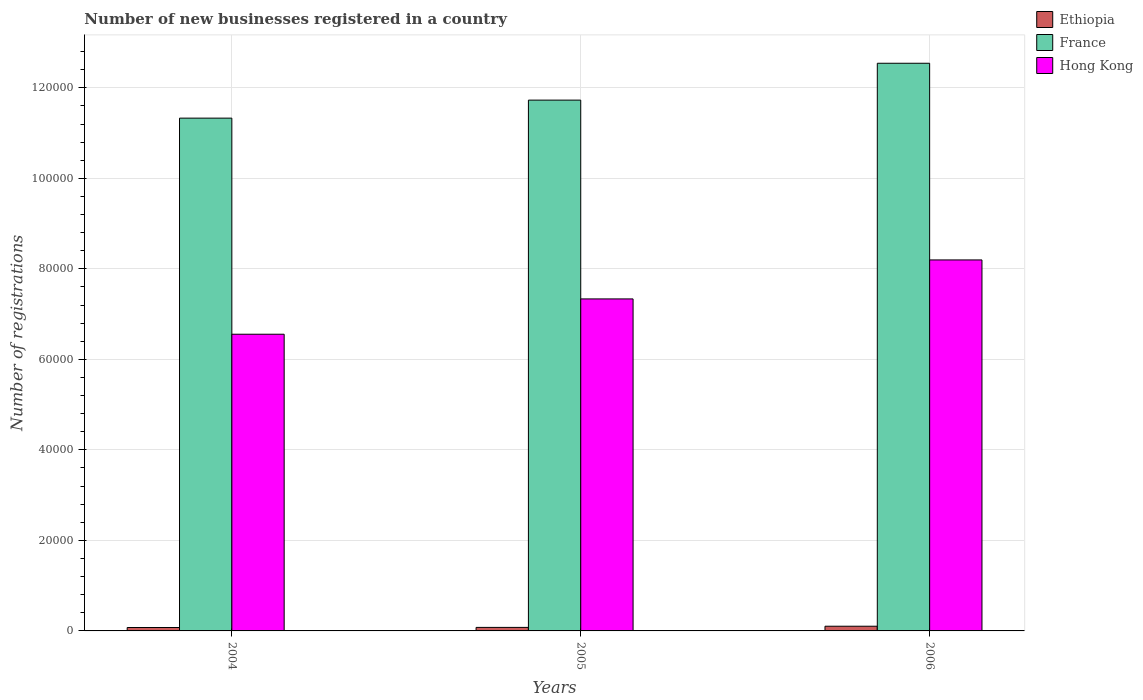How many groups of bars are there?
Offer a very short reply. 3. How many bars are there on the 3rd tick from the right?
Give a very brief answer. 3. What is the number of new businesses registered in France in 2005?
Make the answer very short. 1.17e+05. Across all years, what is the maximum number of new businesses registered in Hong Kong?
Provide a succinct answer. 8.20e+04. Across all years, what is the minimum number of new businesses registered in Hong Kong?
Your answer should be compact. 6.56e+04. In which year was the number of new businesses registered in France maximum?
Provide a succinct answer. 2006. In which year was the number of new businesses registered in Hong Kong minimum?
Offer a very short reply. 2004. What is the total number of new businesses registered in Hong Kong in the graph?
Your answer should be compact. 2.21e+05. What is the difference between the number of new businesses registered in France in 2004 and that in 2006?
Make the answer very short. -1.21e+04. What is the difference between the number of new businesses registered in Hong Kong in 2005 and the number of new businesses registered in Ethiopia in 2004?
Ensure brevity in your answer.  7.26e+04. What is the average number of new businesses registered in Ethiopia per year?
Offer a terse response. 856.33. In the year 2005, what is the difference between the number of new businesses registered in France and number of new businesses registered in Hong Kong?
Your answer should be compact. 4.39e+04. What is the ratio of the number of new businesses registered in Hong Kong in 2005 to that in 2006?
Your answer should be compact. 0.89. Is the number of new businesses registered in Ethiopia in 2004 less than that in 2005?
Your response must be concise. Yes. What is the difference between the highest and the second highest number of new businesses registered in Ethiopia?
Give a very brief answer. 259. What is the difference between the highest and the lowest number of new businesses registered in Ethiopia?
Provide a succinct answer. 283. In how many years, is the number of new businesses registered in Ethiopia greater than the average number of new businesses registered in Ethiopia taken over all years?
Keep it short and to the point. 1. What does the 2nd bar from the left in 2006 represents?
Keep it short and to the point. France. What does the 1st bar from the right in 2004 represents?
Ensure brevity in your answer.  Hong Kong. Is it the case that in every year, the sum of the number of new businesses registered in Ethiopia and number of new businesses registered in France is greater than the number of new businesses registered in Hong Kong?
Offer a very short reply. Yes. How many bars are there?
Your response must be concise. 9. How many years are there in the graph?
Make the answer very short. 3. Are the values on the major ticks of Y-axis written in scientific E-notation?
Your answer should be compact. No. Does the graph contain grids?
Make the answer very short. Yes. Where does the legend appear in the graph?
Make the answer very short. Top right. What is the title of the graph?
Provide a succinct answer. Number of new businesses registered in a country. What is the label or title of the Y-axis?
Offer a very short reply. Number of registrations. What is the Number of registrations of Ethiopia in 2004?
Offer a terse response. 754. What is the Number of registrations in France in 2004?
Your answer should be very brief. 1.13e+05. What is the Number of registrations of Hong Kong in 2004?
Give a very brief answer. 6.56e+04. What is the Number of registrations of Ethiopia in 2005?
Your answer should be very brief. 778. What is the Number of registrations in France in 2005?
Your answer should be very brief. 1.17e+05. What is the Number of registrations in Hong Kong in 2005?
Make the answer very short. 7.34e+04. What is the Number of registrations of Ethiopia in 2006?
Your response must be concise. 1037. What is the Number of registrations in France in 2006?
Keep it short and to the point. 1.25e+05. What is the Number of registrations in Hong Kong in 2006?
Offer a very short reply. 8.20e+04. Across all years, what is the maximum Number of registrations in Ethiopia?
Keep it short and to the point. 1037. Across all years, what is the maximum Number of registrations of France?
Give a very brief answer. 1.25e+05. Across all years, what is the maximum Number of registrations of Hong Kong?
Keep it short and to the point. 8.20e+04. Across all years, what is the minimum Number of registrations in Ethiopia?
Give a very brief answer. 754. Across all years, what is the minimum Number of registrations of France?
Provide a succinct answer. 1.13e+05. Across all years, what is the minimum Number of registrations of Hong Kong?
Ensure brevity in your answer.  6.56e+04. What is the total Number of registrations of Ethiopia in the graph?
Your response must be concise. 2569. What is the total Number of registrations of France in the graph?
Your response must be concise. 3.56e+05. What is the total Number of registrations in Hong Kong in the graph?
Offer a very short reply. 2.21e+05. What is the difference between the Number of registrations of Ethiopia in 2004 and that in 2005?
Ensure brevity in your answer.  -24. What is the difference between the Number of registrations in France in 2004 and that in 2005?
Ensure brevity in your answer.  -3981. What is the difference between the Number of registrations in Hong Kong in 2004 and that in 2005?
Provide a succinct answer. -7801. What is the difference between the Number of registrations in Ethiopia in 2004 and that in 2006?
Ensure brevity in your answer.  -283. What is the difference between the Number of registrations of France in 2004 and that in 2006?
Your answer should be very brief. -1.21e+04. What is the difference between the Number of registrations in Hong Kong in 2004 and that in 2006?
Offer a terse response. -1.64e+04. What is the difference between the Number of registrations in Ethiopia in 2005 and that in 2006?
Provide a short and direct response. -259. What is the difference between the Number of registrations of France in 2005 and that in 2006?
Offer a terse response. -8145. What is the difference between the Number of registrations in Hong Kong in 2005 and that in 2006?
Offer a very short reply. -8615. What is the difference between the Number of registrations in Ethiopia in 2004 and the Number of registrations in France in 2005?
Make the answer very short. -1.17e+05. What is the difference between the Number of registrations of Ethiopia in 2004 and the Number of registrations of Hong Kong in 2005?
Offer a terse response. -7.26e+04. What is the difference between the Number of registrations of France in 2004 and the Number of registrations of Hong Kong in 2005?
Your response must be concise. 3.99e+04. What is the difference between the Number of registrations in Ethiopia in 2004 and the Number of registrations in France in 2006?
Keep it short and to the point. -1.25e+05. What is the difference between the Number of registrations of Ethiopia in 2004 and the Number of registrations of Hong Kong in 2006?
Your answer should be compact. -8.12e+04. What is the difference between the Number of registrations in France in 2004 and the Number of registrations in Hong Kong in 2006?
Give a very brief answer. 3.13e+04. What is the difference between the Number of registrations in Ethiopia in 2005 and the Number of registrations in France in 2006?
Keep it short and to the point. -1.25e+05. What is the difference between the Number of registrations of Ethiopia in 2005 and the Number of registrations of Hong Kong in 2006?
Provide a short and direct response. -8.12e+04. What is the difference between the Number of registrations in France in 2005 and the Number of registrations in Hong Kong in 2006?
Give a very brief answer. 3.53e+04. What is the average Number of registrations in Ethiopia per year?
Give a very brief answer. 856.33. What is the average Number of registrations of France per year?
Give a very brief answer. 1.19e+05. What is the average Number of registrations in Hong Kong per year?
Give a very brief answer. 7.36e+04. In the year 2004, what is the difference between the Number of registrations in Ethiopia and Number of registrations in France?
Offer a very short reply. -1.13e+05. In the year 2004, what is the difference between the Number of registrations of Ethiopia and Number of registrations of Hong Kong?
Give a very brief answer. -6.48e+04. In the year 2004, what is the difference between the Number of registrations in France and Number of registrations in Hong Kong?
Provide a short and direct response. 4.77e+04. In the year 2005, what is the difference between the Number of registrations of Ethiopia and Number of registrations of France?
Provide a succinct answer. -1.17e+05. In the year 2005, what is the difference between the Number of registrations of Ethiopia and Number of registrations of Hong Kong?
Offer a terse response. -7.26e+04. In the year 2005, what is the difference between the Number of registrations in France and Number of registrations in Hong Kong?
Offer a very short reply. 4.39e+04. In the year 2006, what is the difference between the Number of registrations in Ethiopia and Number of registrations in France?
Offer a very short reply. -1.24e+05. In the year 2006, what is the difference between the Number of registrations of Ethiopia and Number of registrations of Hong Kong?
Make the answer very short. -8.09e+04. In the year 2006, what is the difference between the Number of registrations in France and Number of registrations in Hong Kong?
Make the answer very short. 4.35e+04. What is the ratio of the Number of registrations of Ethiopia in 2004 to that in 2005?
Ensure brevity in your answer.  0.97. What is the ratio of the Number of registrations in France in 2004 to that in 2005?
Offer a terse response. 0.97. What is the ratio of the Number of registrations of Hong Kong in 2004 to that in 2005?
Your answer should be very brief. 0.89. What is the ratio of the Number of registrations in Ethiopia in 2004 to that in 2006?
Your answer should be compact. 0.73. What is the ratio of the Number of registrations in France in 2004 to that in 2006?
Your answer should be very brief. 0.9. What is the ratio of the Number of registrations in Hong Kong in 2004 to that in 2006?
Give a very brief answer. 0.8. What is the ratio of the Number of registrations in Ethiopia in 2005 to that in 2006?
Your answer should be very brief. 0.75. What is the ratio of the Number of registrations in France in 2005 to that in 2006?
Provide a short and direct response. 0.94. What is the ratio of the Number of registrations of Hong Kong in 2005 to that in 2006?
Give a very brief answer. 0.89. What is the difference between the highest and the second highest Number of registrations of Ethiopia?
Give a very brief answer. 259. What is the difference between the highest and the second highest Number of registrations of France?
Give a very brief answer. 8145. What is the difference between the highest and the second highest Number of registrations of Hong Kong?
Give a very brief answer. 8615. What is the difference between the highest and the lowest Number of registrations of Ethiopia?
Give a very brief answer. 283. What is the difference between the highest and the lowest Number of registrations of France?
Provide a short and direct response. 1.21e+04. What is the difference between the highest and the lowest Number of registrations in Hong Kong?
Offer a terse response. 1.64e+04. 